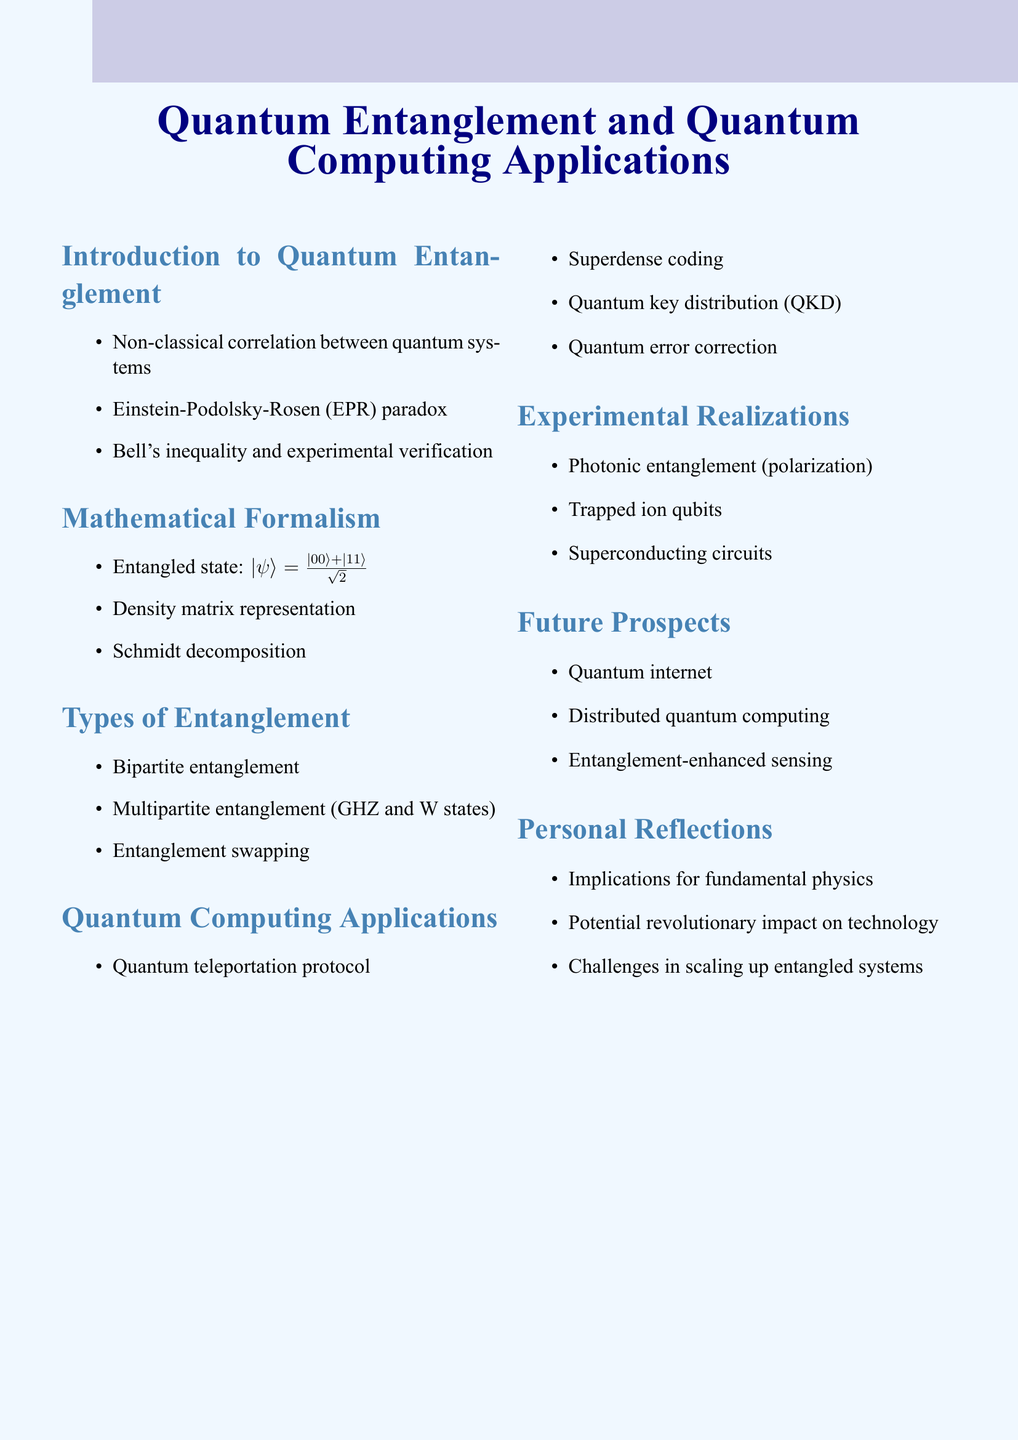What is the definition of quantum entanglement? The document defines quantum entanglement as a non-classical correlation between quantum systems.
Answer: Non-classical correlation Name the type of entanglement that involves multiple parties. The document mentions multipartite entanglement as one of the types of entanglement.
Answer: Multipartite entanglement What protocol is used in quantum teleportation? The document lists the quantum teleportation protocol as an application of quantum computing.
Answer: Quantum teleportation protocol What is a future prospect mentioned in the document? The document discusses various future prospects, one of which is the quantum internet.
Answer: Quantum internet Which experiment is mentioned under experimental realizations? Photonic entanglement (polarization) is listed as one of the experimental realizations in the document.
Answer: Photonic entanglement (polarization) What does the document suggest about the challenges in scaling systems? The document notes challenges in scaling up entangled systems as a personal reflection.
Answer: Challenges in scaling up entangled systems What are quantum key distributions used for? The document includes quantum key distribution (QKD) as an application related to quantum computing.
Answer: Quantum key distribution (QKD) Which state is used in entanglement swapping? The document does not explicitly state a type of state associated with entanglement swapping, but it mentions it as a type of entanglement.
Answer: Entanglement swapping 